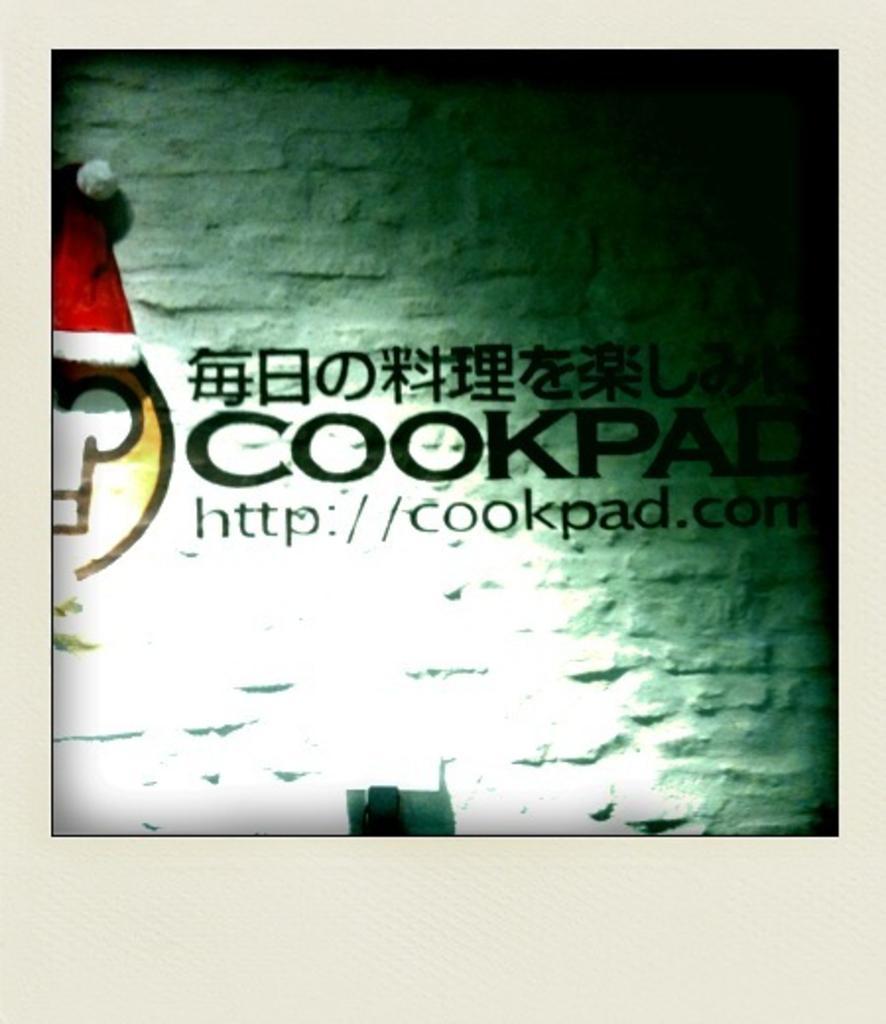Can you describe this image briefly? This is a photo and here we can see some text and there is a logo on the wall. 